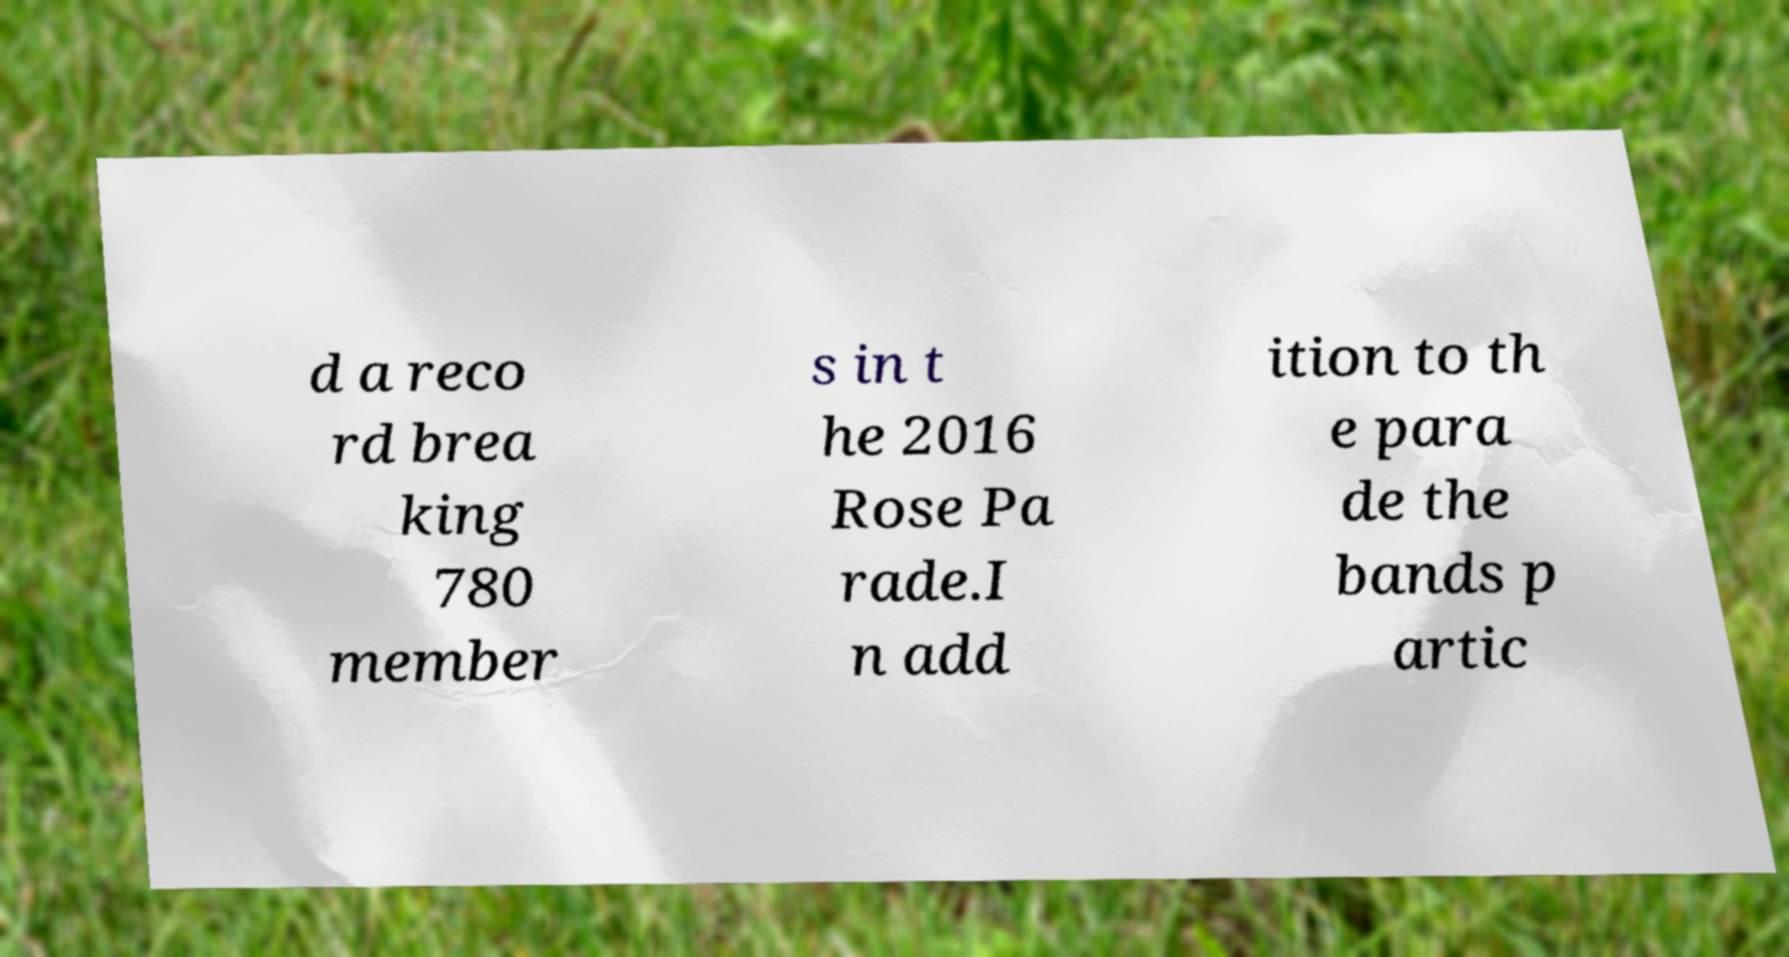Could you assist in decoding the text presented in this image and type it out clearly? d a reco rd brea king 780 member s in t he 2016 Rose Pa rade.I n add ition to th e para de the bands p artic 